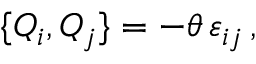<formula> <loc_0><loc_0><loc_500><loc_500>\{ Q _ { i } , Q _ { j } \} = - \theta \, \varepsilon _ { i j } \, ,</formula> 